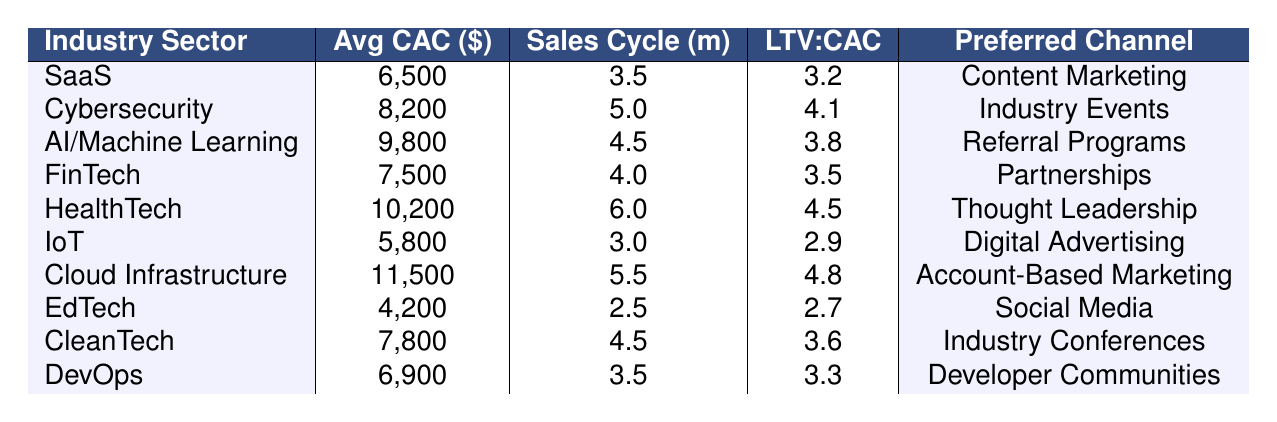What is the average Customer Acquisition Cost (CAC) for HealthTech? The table shows that the average CAC for HealthTech is listed as $10,200.
Answer: $10,200 Which industry sector has the lowest average CAC? By examining the table, IoT is indicated as having the lowest average CAC at $5,800.
Answer: $5,800 What is the LTV:CAC ratio for Cybersecurity? The table indicates that the LTV:CAC ratio for the Cybersecurity sector is 4.1.
Answer: 4.1 How does the average CAC of AI/Machine Learning compare to that of DevOps? AI/Machine Learning has an average CAC of $9,800, while DevOps has an average CAC of $6,900. The difference is $9,800 - $6,900 = $2,900, making AI/Machine Learning more expensive to acquire customers by this amount.
Answer: $2,900 Is the preferred acquisition channel for FinTech partnerships? Yes, the table confirms that the preferred acquisition channel for the FinTech industry is indeed partnerships.
Answer: Yes Calculate the average sales cycle for all sectors. The sales cycles from the table sum up to 37 months (3.5 + 5.0 + 4.5 + 4.0 + 6.0 + 3.0 + 5.5 + 2.5 + 4.5 + 3.5 = 37). There are 10 sectors, so the average sales cycle is 37 months / 10 = 3.7 months.
Answer: 3.7 months What sector has the highest LTV:CAC ratio? By comparing the LTV:CAC ratios in the table, Cloud Infrastructure has the highest ratio of 4.8.
Answer: 4.8 If we sum the average CACs of EdTech and IoT, what is the result? The average CAC for EdTech is $4,200 and for IoT is $5,800. The sum is $4,200 + $5,800 = $10,000.
Answer: $10,000 What is the sales cycle for the Cloud Infrastructure sector? The table indicates that the sales cycle for the Cloud Infrastructure sector is 5.5 months.
Answer: 5.5 months Which acquisition channel is preferred by the HealthTech industry? According to the table, HealthTech's preferred acquisition channel is Thought Leadership.
Answer: Thought Leadership 